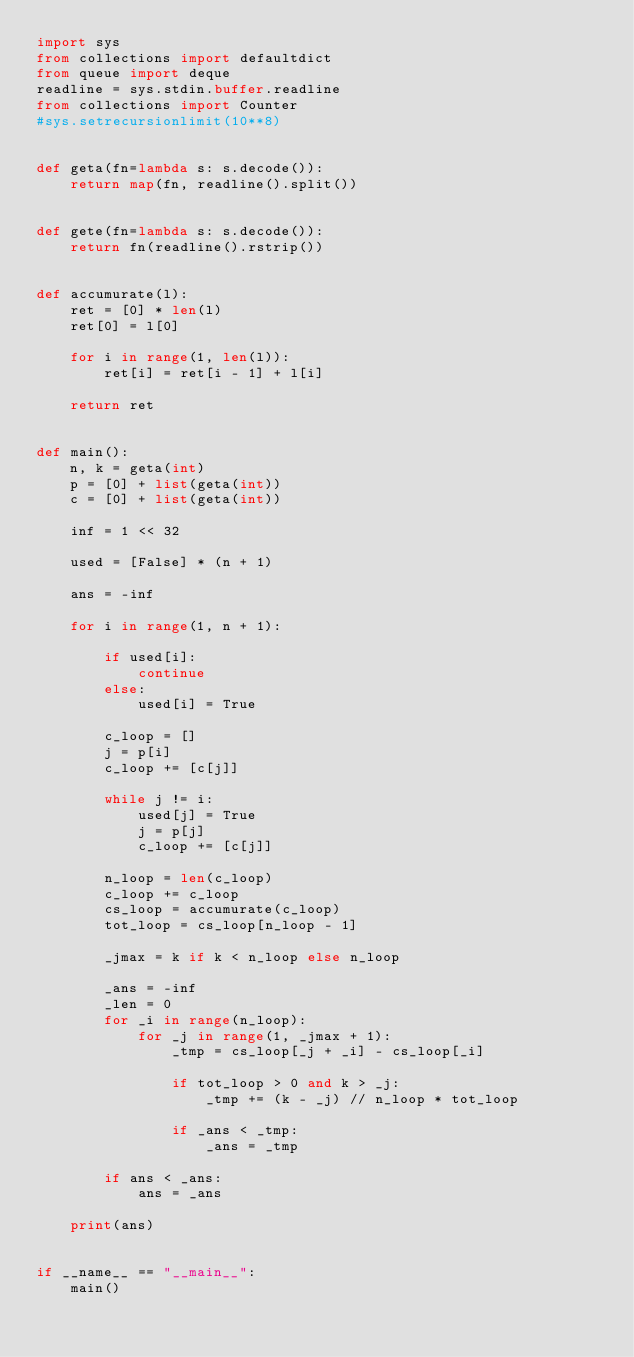<code> <loc_0><loc_0><loc_500><loc_500><_Python_>import sys
from collections import defaultdict
from queue import deque
readline = sys.stdin.buffer.readline
from collections import Counter
#sys.setrecursionlimit(10**8)


def geta(fn=lambda s: s.decode()):
    return map(fn, readline().split())


def gete(fn=lambda s: s.decode()):
    return fn(readline().rstrip())


def accumurate(l):
    ret = [0] * len(l)
    ret[0] = l[0]

    for i in range(1, len(l)):
        ret[i] = ret[i - 1] + l[i]

    return ret


def main():
    n, k = geta(int)
    p = [0] + list(geta(int))
    c = [0] + list(geta(int))

    inf = 1 << 32

    used = [False] * (n + 1)

    ans = -inf

    for i in range(1, n + 1):

        if used[i]:
            continue
        else:
            used[i] = True

        c_loop = []
        j = p[i]
        c_loop += [c[j]]

        while j != i:
            used[j] = True
            j = p[j]
            c_loop += [c[j]]

        n_loop = len(c_loop)
        c_loop += c_loop
        cs_loop = accumurate(c_loop)
        tot_loop = cs_loop[n_loop - 1]

        _jmax = k if k < n_loop else n_loop

        _ans = -inf
        _len = 0
        for _i in range(n_loop):
            for _j in range(1, _jmax + 1):
                _tmp = cs_loop[_j + _i] - cs_loop[_i]

                if tot_loop > 0 and k > _j:
                    _tmp += (k - _j) // n_loop * tot_loop

                if _ans < _tmp:
                    _ans = _tmp

        if ans < _ans:
            ans = _ans

    print(ans)


if __name__ == "__main__":
    main()</code> 